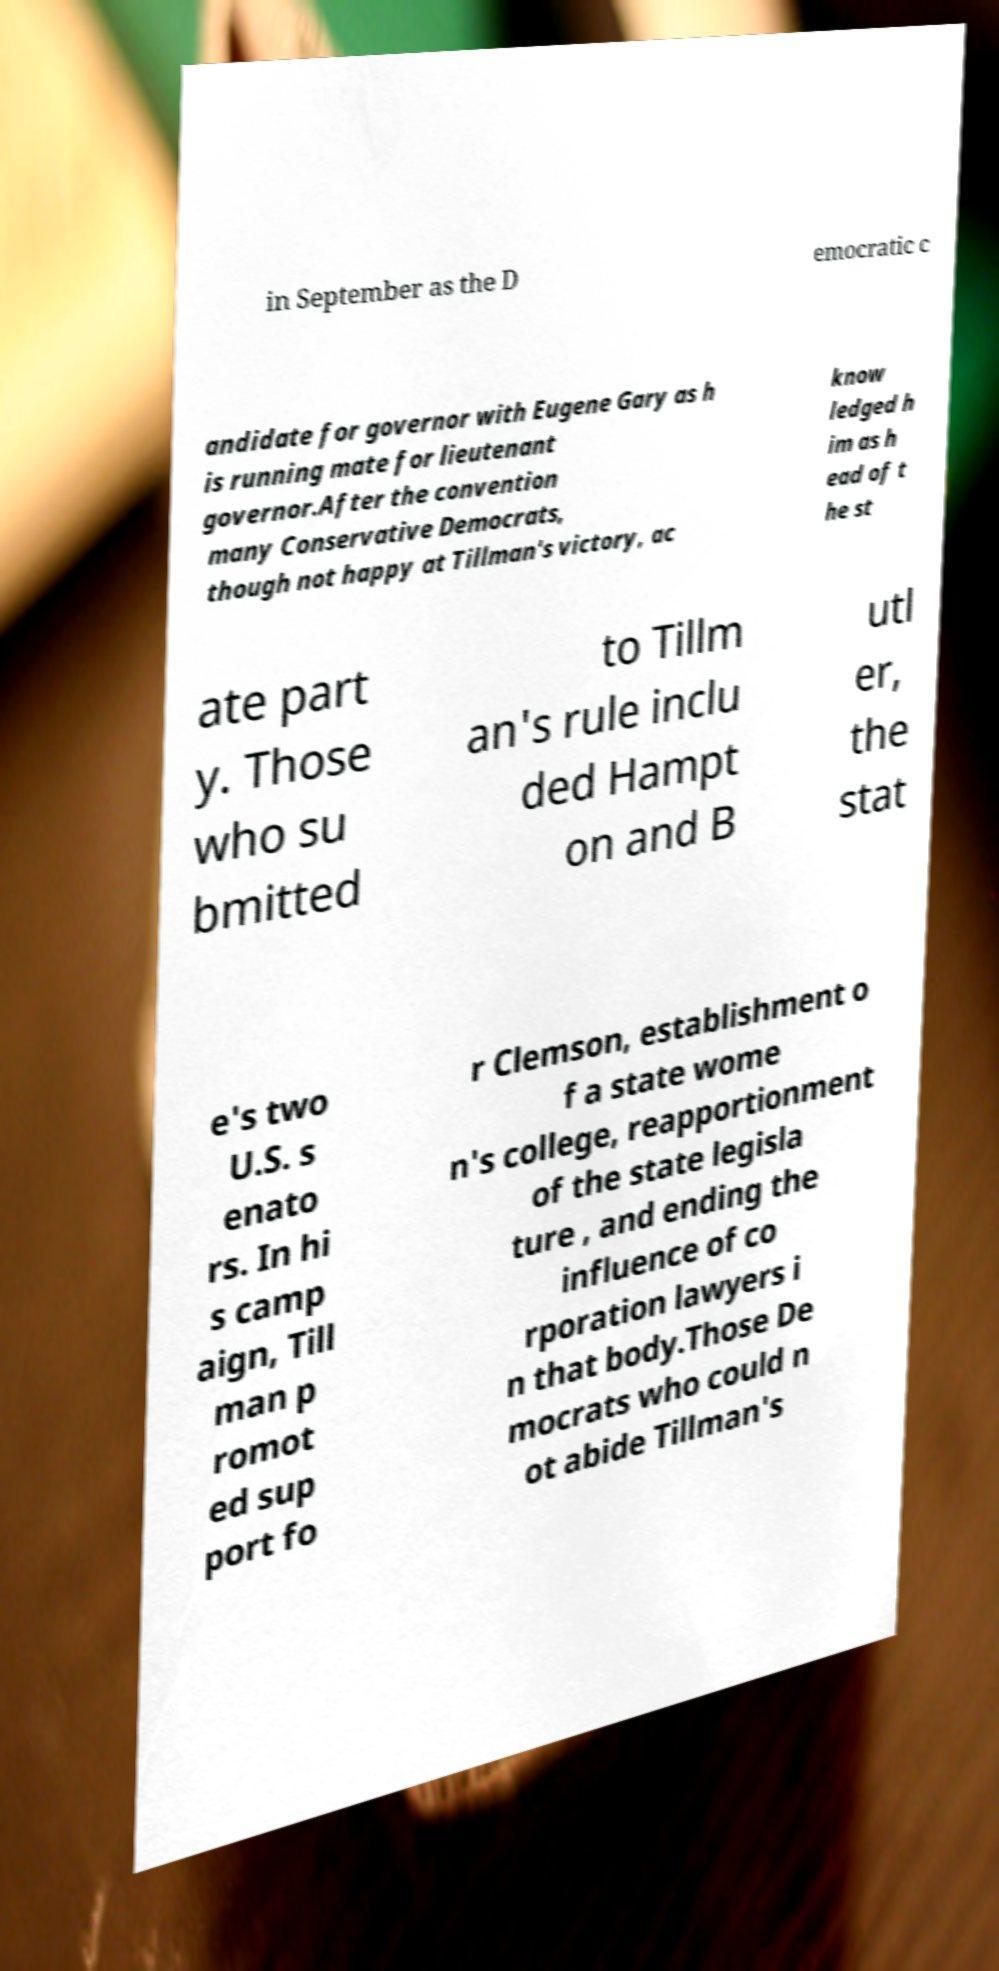Please read and relay the text visible in this image. What does it say? in September as the D emocratic c andidate for governor with Eugene Gary as h is running mate for lieutenant governor.After the convention many Conservative Democrats, though not happy at Tillman's victory, ac know ledged h im as h ead of t he st ate part y. Those who su bmitted to Tillm an's rule inclu ded Hampt on and B utl er, the stat e's two U.S. s enato rs. In hi s camp aign, Till man p romot ed sup port fo r Clemson, establishment o f a state wome n's college, reapportionment of the state legisla ture , and ending the influence of co rporation lawyers i n that body.Those De mocrats who could n ot abide Tillman's 